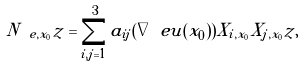Convert formula to latex. <formula><loc_0><loc_0><loc_500><loc_500>N _ { \ e , x _ { 0 } } z = \sum _ { i , j = 1 } ^ { 3 } a _ { i j } ( \nabla _ { \ } e u ( x _ { 0 } ) ) X _ { i , x _ { 0 } } X _ { j , x _ { 0 } } z ,</formula> 